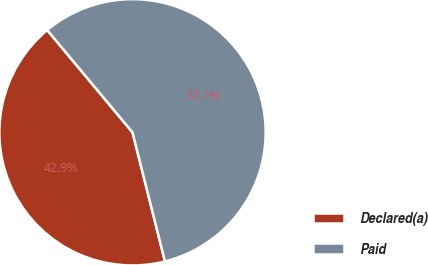Convert chart. <chart><loc_0><loc_0><loc_500><loc_500><pie_chart><fcel>Declared(a)<fcel>Paid<nl><fcel>42.86%<fcel>57.14%<nl></chart> 